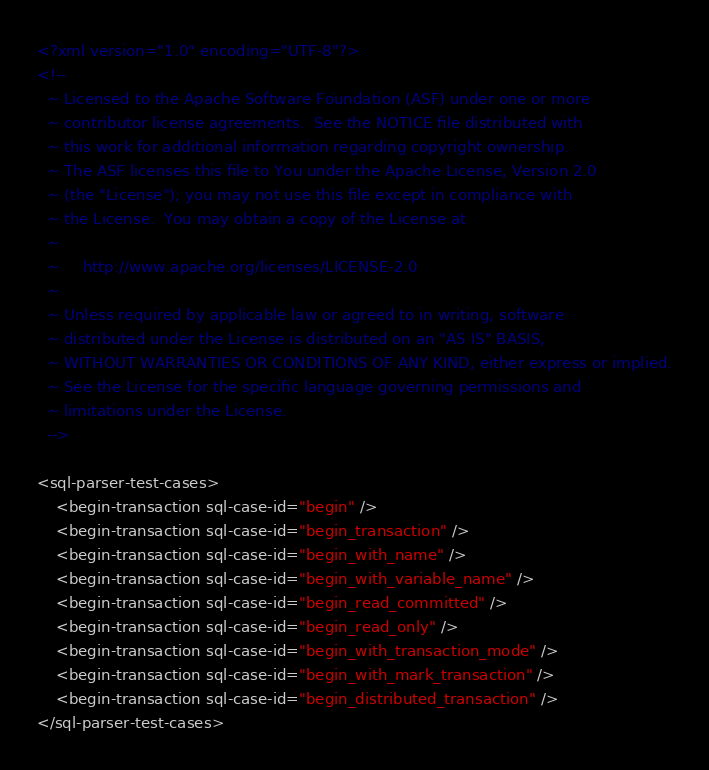<code> <loc_0><loc_0><loc_500><loc_500><_XML_><?xml version="1.0" encoding="UTF-8"?>
<!--
  ~ Licensed to the Apache Software Foundation (ASF) under one or more
  ~ contributor license agreements.  See the NOTICE file distributed with
  ~ this work for additional information regarding copyright ownership.
  ~ The ASF licenses this file to You under the Apache License, Version 2.0
  ~ (the "License"); you may not use this file except in compliance with
  ~ the License.  You may obtain a copy of the License at
  ~
  ~     http://www.apache.org/licenses/LICENSE-2.0
  ~
  ~ Unless required by applicable law or agreed to in writing, software
  ~ distributed under the License is distributed on an "AS IS" BASIS,
  ~ WITHOUT WARRANTIES OR CONDITIONS OF ANY KIND, either express or implied.
  ~ See the License for the specific language governing permissions and
  ~ limitations under the License.
  -->

<sql-parser-test-cases>
    <begin-transaction sql-case-id="begin" />
    <begin-transaction sql-case-id="begin_transaction" />
    <begin-transaction sql-case-id="begin_with_name" />
    <begin-transaction sql-case-id="begin_with_variable_name" />
    <begin-transaction sql-case-id="begin_read_committed" />
    <begin-transaction sql-case-id="begin_read_only" />
    <begin-transaction sql-case-id="begin_with_transaction_mode" />
    <begin-transaction sql-case-id="begin_with_mark_transaction" />
    <begin-transaction sql-case-id="begin_distributed_transaction" />
</sql-parser-test-cases>
</code> 